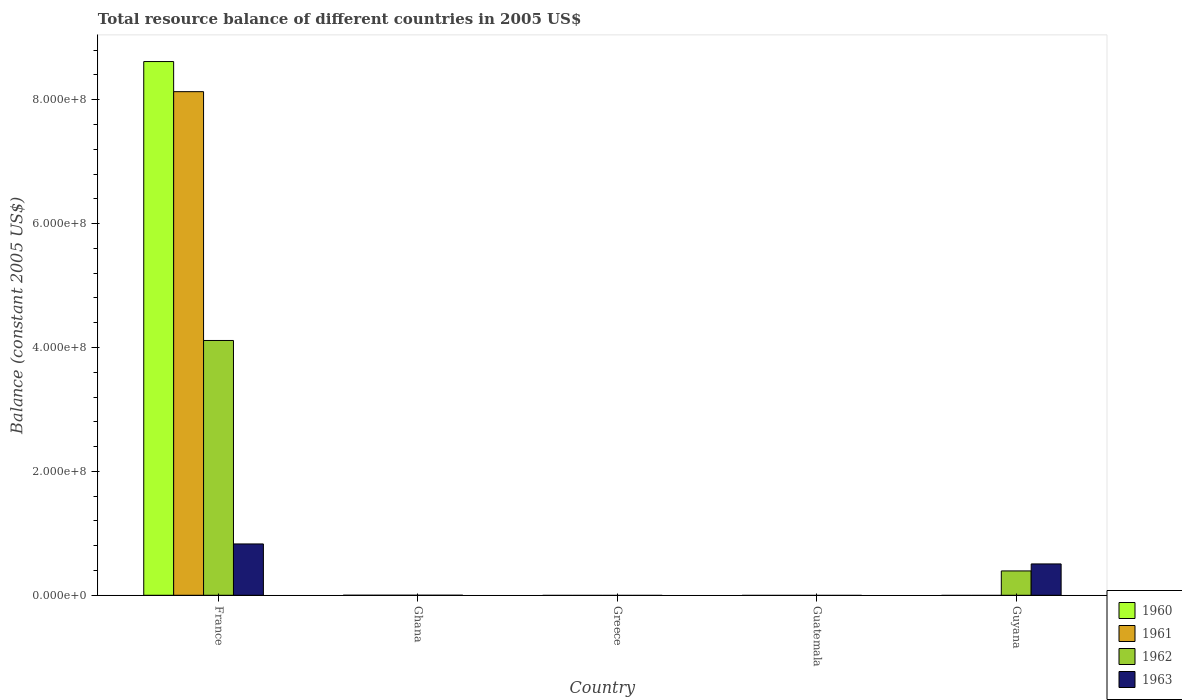How many bars are there on the 5th tick from the left?
Provide a short and direct response. 2. What is the label of the 1st group of bars from the left?
Make the answer very short. France. In how many cases, is the number of bars for a given country not equal to the number of legend labels?
Provide a succinct answer. 4. Across all countries, what is the maximum total resource balance in 1963?
Offer a terse response. 8.29e+07. Across all countries, what is the minimum total resource balance in 1963?
Your answer should be very brief. 0. In which country was the total resource balance in 1961 maximum?
Your answer should be compact. France. What is the total total resource balance in 1963 in the graph?
Ensure brevity in your answer.  1.33e+08. What is the difference between the total resource balance in 1961 in France and the total resource balance in 1963 in Ghana?
Offer a terse response. 8.13e+08. What is the average total resource balance in 1962 per country?
Provide a succinct answer. 9.01e+07. What is the difference between the total resource balance of/in 1961 and total resource balance of/in 1963 in France?
Your answer should be very brief. 7.30e+08. In how many countries, is the total resource balance in 1963 greater than 440000000 US$?
Keep it short and to the point. 0. Is the total resource balance in 1963 in France less than that in Guyana?
Give a very brief answer. No. What is the difference between the highest and the lowest total resource balance in 1960?
Provide a short and direct response. 8.62e+08. Is it the case that in every country, the sum of the total resource balance in 1962 and total resource balance in 1961 is greater than the total resource balance in 1960?
Provide a short and direct response. No. What is the difference between two consecutive major ticks on the Y-axis?
Give a very brief answer. 2.00e+08. Are the values on the major ticks of Y-axis written in scientific E-notation?
Give a very brief answer. Yes. Does the graph contain any zero values?
Provide a short and direct response. Yes. How many legend labels are there?
Ensure brevity in your answer.  4. How are the legend labels stacked?
Keep it short and to the point. Vertical. What is the title of the graph?
Your answer should be compact. Total resource balance of different countries in 2005 US$. Does "1994" appear as one of the legend labels in the graph?
Your response must be concise. No. What is the label or title of the Y-axis?
Provide a succinct answer. Balance (constant 2005 US$). What is the Balance (constant 2005 US$) in 1960 in France?
Offer a terse response. 8.62e+08. What is the Balance (constant 2005 US$) in 1961 in France?
Your answer should be very brief. 8.13e+08. What is the Balance (constant 2005 US$) of 1962 in France?
Provide a short and direct response. 4.11e+08. What is the Balance (constant 2005 US$) of 1963 in France?
Give a very brief answer. 8.29e+07. What is the Balance (constant 2005 US$) in 1961 in Ghana?
Your response must be concise. 0. What is the Balance (constant 2005 US$) in 1962 in Ghana?
Provide a short and direct response. 0. What is the Balance (constant 2005 US$) of 1960 in Greece?
Your response must be concise. 0. What is the Balance (constant 2005 US$) of 1961 in Greece?
Offer a very short reply. 0. What is the Balance (constant 2005 US$) in 1962 in Greece?
Your answer should be compact. 0. What is the Balance (constant 2005 US$) of 1962 in Guatemala?
Make the answer very short. 0. What is the Balance (constant 2005 US$) of 1961 in Guyana?
Your answer should be compact. 0. What is the Balance (constant 2005 US$) in 1962 in Guyana?
Ensure brevity in your answer.  3.93e+07. What is the Balance (constant 2005 US$) of 1963 in Guyana?
Give a very brief answer. 5.06e+07. Across all countries, what is the maximum Balance (constant 2005 US$) in 1960?
Offer a very short reply. 8.62e+08. Across all countries, what is the maximum Balance (constant 2005 US$) of 1961?
Your answer should be compact. 8.13e+08. Across all countries, what is the maximum Balance (constant 2005 US$) of 1962?
Provide a short and direct response. 4.11e+08. Across all countries, what is the maximum Balance (constant 2005 US$) of 1963?
Offer a terse response. 8.29e+07. Across all countries, what is the minimum Balance (constant 2005 US$) in 1960?
Offer a very short reply. 0. Across all countries, what is the minimum Balance (constant 2005 US$) in 1961?
Provide a succinct answer. 0. Across all countries, what is the minimum Balance (constant 2005 US$) of 1963?
Ensure brevity in your answer.  0. What is the total Balance (constant 2005 US$) of 1960 in the graph?
Keep it short and to the point. 8.62e+08. What is the total Balance (constant 2005 US$) in 1961 in the graph?
Offer a very short reply. 8.13e+08. What is the total Balance (constant 2005 US$) of 1962 in the graph?
Your answer should be compact. 4.51e+08. What is the total Balance (constant 2005 US$) of 1963 in the graph?
Give a very brief answer. 1.33e+08. What is the difference between the Balance (constant 2005 US$) of 1962 in France and that in Guyana?
Ensure brevity in your answer.  3.72e+08. What is the difference between the Balance (constant 2005 US$) in 1963 in France and that in Guyana?
Keep it short and to the point. 3.23e+07. What is the difference between the Balance (constant 2005 US$) in 1960 in France and the Balance (constant 2005 US$) in 1962 in Guyana?
Give a very brief answer. 8.22e+08. What is the difference between the Balance (constant 2005 US$) in 1960 in France and the Balance (constant 2005 US$) in 1963 in Guyana?
Your answer should be very brief. 8.11e+08. What is the difference between the Balance (constant 2005 US$) of 1961 in France and the Balance (constant 2005 US$) of 1962 in Guyana?
Your response must be concise. 7.74e+08. What is the difference between the Balance (constant 2005 US$) of 1961 in France and the Balance (constant 2005 US$) of 1963 in Guyana?
Ensure brevity in your answer.  7.62e+08. What is the difference between the Balance (constant 2005 US$) of 1962 in France and the Balance (constant 2005 US$) of 1963 in Guyana?
Keep it short and to the point. 3.61e+08. What is the average Balance (constant 2005 US$) in 1960 per country?
Your answer should be compact. 1.72e+08. What is the average Balance (constant 2005 US$) in 1961 per country?
Your answer should be very brief. 1.63e+08. What is the average Balance (constant 2005 US$) in 1962 per country?
Ensure brevity in your answer.  9.01e+07. What is the average Balance (constant 2005 US$) of 1963 per country?
Make the answer very short. 2.67e+07. What is the difference between the Balance (constant 2005 US$) in 1960 and Balance (constant 2005 US$) in 1961 in France?
Keep it short and to the point. 4.86e+07. What is the difference between the Balance (constant 2005 US$) in 1960 and Balance (constant 2005 US$) in 1962 in France?
Keep it short and to the point. 4.50e+08. What is the difference between the Balance (constant 2005 US$) of 1960 and Balance (constant 2005 US$) of 1963 in France?
Provide a succinct answer. 7.79e+08. What is the difference between the Balance (constant 2005 US$) of 1961 and Balance (constant 2005 US$) of 1962 in France?
Your answer should be compact. 4.02e+08. What is the difference between the Balance (constant 2005 US$) in 1961 and Balance (constant 2005 US$) in 1963 in France?
Ensure brevity in your answer.  7.30e+08. What is the difference between the Balance (constant 2005 US$) in 1962 and Balance (constant 2005 US$) in 1963 in France?
Keep it short and to the point. 3.28e+08. What is the difference between the Balance (constant 2005 US$) of 1962 and Balance (constant 2005 US$) of 1963 in Guyana?
Give a very brief answer. -1.13e+07. What is the ratio of the Balance (constant 2005 US$) of 1962 in France to that in Guyana?
Ensure brevity in your answer.  10.47. What is the ratio of the Balance (constant 2005 US$) in 1963 in France to that in Guyana?
Offer a terse response. 1.64. What is the difference between the highest and the lowest Balance (constant 2005 US$) of 1960?
Ensure brevity in your answer.  8.62e+08. What is the difference between the highest and the lowest Balance (constant 2005 US$) in 1961?
Give a very brief answer. 8.13e+08. What is the difference between the highest and the lowest Balance (constant 2005 US$) in 1962?
Your response must be concise. 4.11e+08. What is the difference between the highest and the lowest Balance (constant 2005 US$) of 1963?
Offer a terse response. 8.29e+07. 